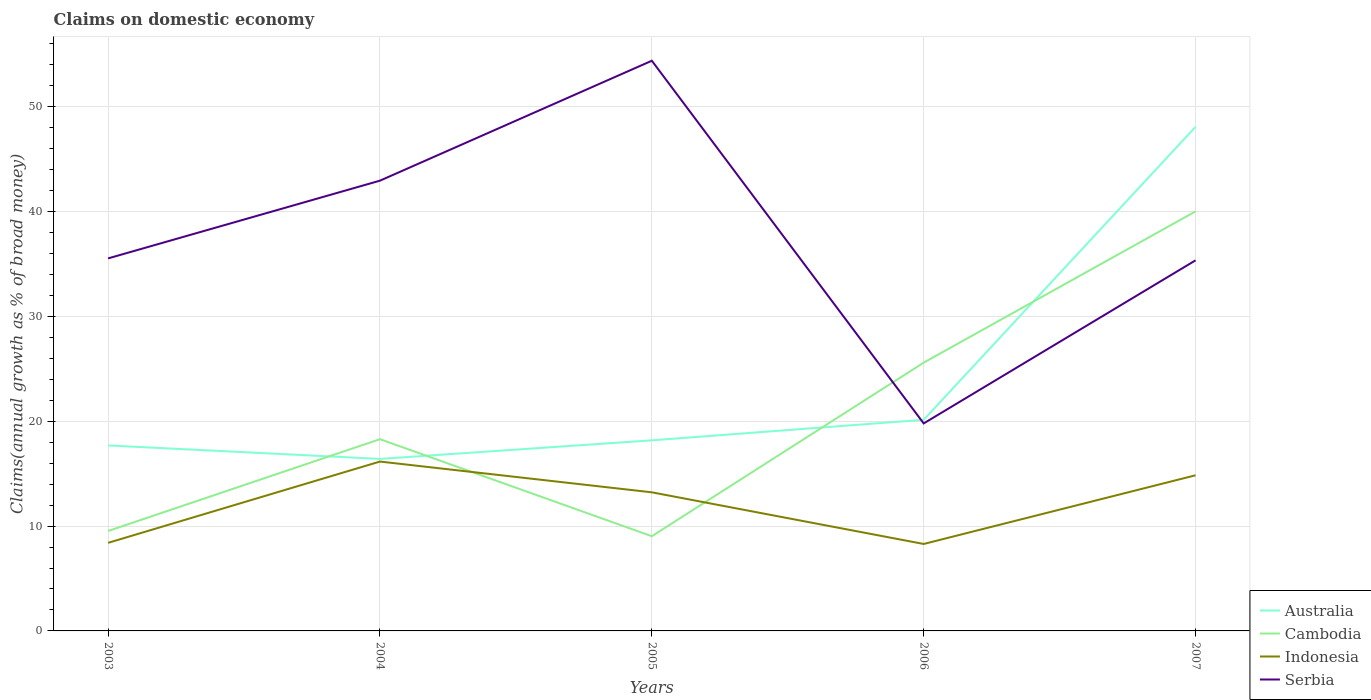How many different coloured lines are there?
Provide a short and direct response. 4. Does the line corresponding to Serbia intersect with the line corresponding to Australia?
Your answer should be very brief. Yes. Across all years, what is the maximum percentage of broad money claimed on domestic economy in Cambodia?
Your answer should be very brief. 9.03. In which year was the percentage of broad money claimed on domestic economy in Cambodia maximum?
Provide a succinct answer. 2005. What is the total percentage of broad money claimed on domestic economy in Cambodia in the graph?
Ensure brevity in your answer.  -30.99. What is the difference between the highest and the second highest percentage of broad money claimed on domestic economy in Serbia?
Your response must be concise. 34.6. What is the difference between the highest and the lowest percentage of broad money claimed on domestic economy in Serbia?
Your response must be concise. 2. Is the percentage of broad money claimed on domestic economy in Serbia strictly greater than the percentage of broad money claimed on domestic economy in Indonesia over the years?
Give a very brief answer. No. How many lines are there?
Ensure brevity in your answer.  4. What is the difference between two consecutive major ticks on the Y-axis?
Your response must be concise. 10. Where does the legend appear in the graph?
Keep it short and to the point. Bottom right. How are the legend labels stacked?
Provide a succinct answer. Vertical. What is the title of the graph?
Provide a succinct answer. Claims on domestic economy. Does "Central African Republic" appear as one of the legend labels in the graph?
Your answer should be very brief. No. What is the label or title of the X-axis?
Offer a terse response. Years. What is the label or title of the Y-axis?
Provide a short and direct response. Claims(annual growth as % of broad money). What is the Claims(annual growth as % of broad money) in Australia in 2003?
Provide a succinct answer. 17.69. What is the Claims(annual growth as % of broad money) of Cambodia in 2003?
Provide a short and direct response. 9.53. What is the Claims(annual growth as % of broad money) in Indonesia in 2003?
Provide a succinct answer. 8.4. What is the Claims(annual growth as % of broad money) in Serbia in 2003?
Offer a terse response. 35.54. What is the Claims(annual growth as % of broad money) of Australia in 2004?
Provide a succinct answer. 16.41. What is the Claims(annual growth as % of broad money) of Cambodia in 2004?
Make the answer very short. 18.29. What is the Claims(annual growth as % of broad money) of Indonesia in 2004?
Your answer should be very brief. 16.16. What is the Claims(annual growth as % of broad money) of Serbia in 2004?
Give a very brief answer. 42.96. What is the Claims(annual growth as % of broad money) of Australia in 2005?
Give a very brief answer. 18.18. What is the Claims(annual growth as % of broad money) of Cambodia in 2005?
Offer a very short reply. 9.03. What is the Claims(annual growth as % of broad money) in Indonesia in 2005?
Make the answer very short. 13.22. What is the Claims(annual growth as % of broad money) in Serbia in 2005?
Offer a very short reply. 54.4. What is the Claims(annual growth as % of broad money) in Australia in 2006?
Your answer should be very brief. 20.14. What is the Claims(annual growth as % of broad money) of Cambodia in 2006?
Your response must be concise. 25.6. What is the Claims(annual growth as % of broad money) of Indonesia in 2006?
Provide a short and direct response. 8.3. What is the Claims(annual growth as % of broad money) of Serbia in 2006?
Provide a succinct answer. 19.8. What is the Claims(annual growth as % of broad money) in Australia in 2007?
Your response must be concise. 48.1. What is the Claims(annual growth as % of broad money) in Cambodia in 2007?
Your response must be concise. 40.02. What is the Claims(annual growth as % of broad money) of Indonesia in 2007?
Your answer should be very brief. 14.85. What is the Claims(annual growth as % of broad money) in Serbia in 2007?
Give a very brief answer. 35.36. Across all years, what is the maximum Claims(annual growth as % of broad money) of Australia?
Your answer should be very brief. 48.1. Across all years, what is the maximum Claims(annual growth as % of broad money) of Cambodia?
Provide a succinct answer. 40.02. Across all years, what is the maximum Claims(annual growth as % of broad money) of Indonesia?
Offer a very short reply. 16.16. Across all years, what is the maximum Claims(annual growth as % of broad money) of Serbia?
Make the answer very short. 54.4. Across all years, what is the minimum Claims(annual growth as % of broad money) in Australia?
Provide a succinct answer. 16.41. Across all years, what is the minimum Claims(annual growth as % of broad money) in Cambodia?
Your answer should be compact. 9.03. Across all years, what is the minimum Claims(annual growth as % of broad money) of Indonesia?
Keep it short and to the point. 8.3. Across all years, what is the minimum Claims(annual growth as % of broad money) in Serbia?
Offer a very short reply. 19.8. What is the total Claims(annual growth as % of broad money) of Australia in the graph?
Make the answer very short. 120.53. What is the total Claims(annual growth as % of broad money) in Cambodia in the graph?
Your answer should be very brief. 102.48. What is the total Claims(annual growth as % of broad money) of Indonesia in the graph?
Provide a short and direct response. 60.93. What is the total Claims(annual growth as % of broad money) of Serbia in the graph?
Provide a short and direct response. 188.04. What is the difference between the Claims(annual growth as % of broad money) of Australia in 2003 and that in 2004?
Offer a very short reply. 1.28. What is the difference between the Claims(annual growth as % of broad money) of Cambodia in 2003 and that in 2004?
Make the answer very short. -8.76. What is the difference between the Claims(annual growth as % of broad money) of Indonesia in 2003 and that in 2004?
Provide a succinct answer. -7.76. What is the difference between the Claims(annual growth as % of broad money) of Serbia in 2003 and that in 2004?
Make the answer very short. -7.42. What is the difference between the Claims(annual growth as % of broad money) of Australia in 2003 and that in 2005?
Provide a short and direct response. -0.49. What is the difference between the Claims(annual growth as % of broad money) in Cambodia in 2003 and that in 2005?
Your answer should be very brief. 0.5. What is the difference between the Claims(annual growth as % of broad money) of Indonesia in 2003 and that in 2005?
Offer a terse response. -4.82. What is the difference between the Claims(annual growth as % of broad money) in Serbia in 2003 and that in 2005?
Offer a very short reply. -18.86. What is the difference between the Claims(annual growth as % of broad money) in Australia in 2003 and that in 2006?
Offer a terse response. -2.45. What is the difference between the Claims(annual growth as % of broad money) in Cambodia in 2003 and that in 2006?
Make the answer very short. -16.06. What is the difference between the Claims(annual growth as % of broad money) in Indonesia in 2003 and that in 2006?
Your response must be concise. 0.11. What is the difference between the Claims(annual growth as % of broad money) of Serbia in 2003 and that in 2006?
Make the answer very short. 15.74. What is the difference between the Claims(annual growth as % of broad money) of Australia in 2003 and that in 2007?
Provide a succinct answer. -30.4. What is the difference between the Claims(annual growth as % of broad money) of Cambodia in 2003 and that in 2007?
Provide a succinct answer. -30.49. What is the difference between the Claims(annual growth as % of broad money) in Indonesia in 2003 and that in 2007?
Your answer should be compact. -6.45. What is the difference between the Claims(annual growth as % of broad money) in Serbia in 2003 and that in 2007?
Your response must be concise. 0.18. What is the difference between the Claims(annual growth as % of broad money) of Australia in 2004 and that in 2005?
Offer a terse response. -1.77. What is the difference between the Claims(annual growth as % of broad money) in Cambodia in 2004 and that in 2005?
Your answer should be very brief. 9.26. What is the difference between the Claims(annual growth as % of broad money) of Indonesia in 2004 and that in 2005?
Give a very brief answer. 2.94. What is the difference between the Claims(annual growth as % of broad money) in Serbia in 2004 and that in 2005?
Ensure brevity in your answer.  -11.44. What is the difference between the Claims(annual growth as % of broad money) in Australia in 2004 and that in 2006?
Keep it short and to the point. -3.73. What is the difference between the Claims(annual growth as % of broad money) of Cambodia in 2004 and that in 2006?
Your response must be concise. -7.3. What is the difference between the Claims(annual growth as % of broad money) of Indonesia in 2004 and that in 2006?
Offer a very short reply. 7.86. What is the difference between the Claims(annual growth as % of broad money) in Serbia in 2004 and that in 2006?
Offer a terse response. 23.16. What is the difference between the Claims(annual growth as % of broad money) in Australia in 2004 and that in 2007?
Offer a terse response. -31.69. What is the difference between the Claims(annual growth as % of broad money) in Cambodia in 2004 and that in 2007?
Your answer should be compact. -21.73. What is the difference between the Claims(annual growth as % of broad money) in Indonesia in 2004 and that in 2007?
Offer a very short reply. 1.31. What is the difference between the Claims(annual growth as % of broad money) in Serbia in 2004 and that in 2007?
Your answer should be compact. 7.6. What is the difference between the Claims(annual growth as % of broad money) of Australia in 2005 and that in 2006?
Your response must be concise. -1.96. What is the difference between the Claims(annual growth as % of broad money) in Cambodia in 2005 and that in 2006?
Your answer should be compact. -16.56. What is the difference between the Claims(annual growth as % of broad money) of Indonesia in 2005 and that in 2006?
Offer a terse response. 4.93. What is the difference between the Claims(annual growth as % of broad money) in Serbia in 2005 and that in 2006?
Provide a short and direct response. 34.6. What is the difference between the Claims(annual growth as % of broad money) in Australia in 2005 and that in 2007?
Keep it short and to the point. -29.91. What is the difference between the Claims(annual growth as % of broad money) in Cambodia in 2005 and that in 2007?
Give a very brief answer. -30.99. What is the difference between the Claims(annual growth as % of broad money) in Indonesia in 2005 and that in 2007?
Provide a short and direct response. -1.63. What is the difference between the Claims(annual growth as % of broad money) of Serbia in 2005 and that in 2007?
Provide a short and direct response. 19.04. What is the difference between the Claims(annual growth as % of broad money) of Australia in 2006 and that in 2007?
Your answer should be compact. -27.95. What is the difference between the Claims(annual growth as % of broad money) of Cambodia in 2006 and that in 2007?
Your answer should be compact. -14.43. What is the difference between the Claims(annual growth as % of broad money) of Indonesia in 2006 and that in 2007?
Offer a terse response. -6.55. What is the difference between the Claims(annual growth as % of broad money) in Serbia in 2006 and that in 2007?
Your response must be concise. -15.56. What is the difference between the Claims(annual growth as % of broad money) in Australia in 2003 and the Claims(annual growth as % of broad money) in Cambodia in 2004?
Offer a terse response. -0.6. What is the difference between the Claims(annual growth as % of broad money) of Australia in 2003 and the Claims(annual growth as % of broad money) of Indonesia in 2004?
Offer a terse response. 1.54. What is the difference between the Claims(annual growth as % of broad money) in Australia in 2003 and the Claims(annual growth as % of broad money) in Serbia in 2004?
Provide a succinct answer. -25.26. What is the difference between the Claims(annual growth as % of broad money) in Cambodia in 2003 and the Claims(annual growth as % of broad money) in Indonesia in 2004?
Provide a succinct answer. -6.63. What is the difference between the Claims(annual growth as % of broad money) of Cambodia in 2003 and the Claims(annual growth as % of broad money) of Serbia in 2004?
Your answer should be very brief. -33.42. What is the difference between the Claims(annual growth as % of broad money) in Indonesia in 2003 and the Claims(annual growth as % of broad money) in Serbia in 2004?
Keep it short and to the point. -34.55. What is the difference between the Claims(annual growth as % of broad money) of Australia in 2003 and the Claims(annual growth as % of broad money) of Cambodia in 2005?
Keep it short and to the point. 8.66. What is the difference between the Claims(annual growth as % of broad money) of Australia in 2003 and the Claims(annual growth as % of broad money) of Indonesia in 2005?
Your answer should be compact. 4.47. What is the difference between the Claims(annual growth as % of broad money) in Australia in 2003 and the Claims(annual growth as % of broad money) in Serbia in 2005?
Provide a succinct answer. -36.7. What is the difference between the Claims(annual growth as % of broad money) in Cambodia in 2003 and the Claims(annual growth as % of broad money) in Indonesia in 2005?
Give a very brief answer. -3.69. What is the difference between the Claims(annual growth as % of broad money) in Cambodia in 2003 and the Claims(annual growth as % of broad money) in Serbia in 2005?
Provide a short and direct response. -44.86. What is the difference between the Claims(annual growth as % of broad money) in Indonesia in 2003 and the Claims(annual growth as % of broad money) in Serbia in 2005?
Your answer should be compact. -45.99. What is the difference between the Claims(annual growth as % of broad money) in Australia in 2003 and the Claims(annual growth as % of broad money) in Cambodia in 2006?
Give a very brief answer. -7.9. What is the difference between the Claims(annual growth as % of broad money) of Australia in 2003 and the Claims(annual growth as % of broad money) of Indonesia in 2006?
Your answer should be very brief. 9.4. What is the difference between the Claims(annual growth as % of broad money) of Australia in 2003 and the Claims(annual growth as % of broad money) of Serbia in 2006?
Provide a succinct answer. -2.1. What is the difference between the Claims(annual growth as % of broad money) in Cambodia in 2003 and the Claims(annual growth as % of broad money) in Indonesia in 2006?
Make the answer very short. 1.24. What is the difference between the Claims(annual growth as % of broad money) in Cambodia in 2003 and the Claims(annual growth as % of broad money) in Serbia in 2006?
Provide a short and direct response. -10.26. What is the difference between the Claims(annual growth as % of broad money) in Indonesia in 2003 and the Claims(annual growth as % of broad money) in Serbia in 2006?
Give a very brief answer. -11.39. What is the difference between the Claims(annual growth as % of broad money) in Australia in 2003 and the Claims(annual growth as % of broad money) in Cambodia in 2007?
Offer a terse response. -22.33. What is the difference between the Claims(annual growth as % of broad money) in Australia in 2003 and the Claims(annual growth as % of broad money) in Indonesia in 2007?
Keep it short and to the point. 2.85. What is the difference between the Claims(annual growth as % of broad money) of Australia in 2003 and the Claims(annual growth as % of broad money) of Serbia in 2007?
Your answer should be very brief. -17.66. What is the difference between the Claims(annual growth as % of broad money) of Cambodia in 2003 and the Claims(annual growth as % of broad money) of Indonesia in 2007?
Your response must be concise. -5.32. What is the difference between the Claims(annual growth as % of broad money) in Cambodia in 2003 and the Claims(annual growth as % of broad money) in Serbia in 2007?
Offer a very short reply. -25.82. What is the difference between the Claims(annual growth as % of broad money) in Indonesia in 2003 and the Claims(annual growth as % of broad money) in Serbia in 2007?
Make the answer very short. -26.95. What is the difference between the Claims(annual growth as % of broad money) of Australia in 2004 and the Claims(annual growth as % of broad money) of Cambodia in 2005?
Offer a terse response. 7.38. What is the difference between the Claims(annual growth as % of broad money) in Australia in 2004 and the Claims(annual growth as % of broad money) in Indonesia in 2005?
Keep it short and to the point. 3.19. What is the difference between the Claims(annual growth as % of broad money) in Australia in 2004 and the Claims(annual growth as % of broad money) in Serbia in 2005?
Ensure brevity in your answer.  -37.99. What is the difference between the Claims(annual growth as % of broad money) of Cambodia in 2004 and the Claims(annual growth as % of broad money) of Indonesia in 2005?
Provide a succinct answer. 5.07. What is the difference between the Claims(annual growth as % of broad money) in Cambodia in 2004 and the Claims(annual growth as % of broad money) in Serbia in 2005?
Provide a short and direct response. -36.1. What is the difference between the Claims(annual growth as % of broad money) of Indonesia in 2004 and the Claims(annual growth as % of broad money) of Serbia in 2005?
Give a very brief answer. -38.24. What is the difference between the Claims(annual growth as % of broad money) in Australia in 2004 and the Claims(annual growth as % of broad money) in Cambodia in 2006?
Your answer should be very brief. -9.19. What is the difference between the Claims(annual growth as % of broad money) in Australia in 2004 and the Claims(annual growth as % of broad money) in Indonesia in 2006?
Your answer should be compact. 8.11. What is the difference between the Claims(annual growth as % of broad money) in Australia in 2004 and the Claims(annual growth as % of broad money) in Serbia in 2006?
Your response must be concise. -3.39. What is the difference between the Claims(annual growth as % of broad money) in Cambodia in 2004 and the Claims(annual growth as % of broad money) in Indonesia in 2006?
Make the answer very short. 10. What is the difference between the Claims(annual growth as % of broad money) of Cambodia in 2004 and the Claims(annual growth as % of broad money) of Serbia in 2006?
Provide a succinct answer. -1.5. What is the difference between the Claims(annual growth as % of broad money) of Indonesia in 2004 and the Claims(annual growth as % of broad money) of Serbia in 2006?
Your response must be concise. -3.64. What is the difference between the Claims(annual growth as % of broad money) of Australia in 2004 and the Claims(annual growth as % of broad money) of Cambodia in 2007?
Provide a short and direct response. -23.61. What is the difference between the Claims(annual growth as % of broad money) in Australia in 2004 and the Claims(annual growth as % of broad money) in Indonesia in 2007?
Give a very brief answer. 1.56. What is the difference between the Claims(annual growth as % of broad money) of Australia in 2004 and the Claims(annual growth as % of broad money) of Serbia in 2007?
Offer a very short reply. -18.94. What is the difference between the Claims(annual growth as % of broad money) in Cambodia in 2004 and the Claims(annual growth as % of broad money) in Indonesia in 2007?
Keep it short and to the point. 3.44. What is the difference between the Claims(annual growth as % of broad money) of Cambodia in 2004 and the Claims(annual growth as % of broad money) of Serbia in 2007?
Keep it short and to the point. -17.06. What is the difference between the Claims(annual growth as % of broad money) in Indonesia in 2004 and the Claims(annual growth as % of broad money) in Serbia in 2007?
Provide a short and direct response. -19.2. What is the difference between the Claims(annual growth as % of broad money) of Australia in 2005 and the Claims(annual growth as % of broad money) of Cambodia in 2006?
Your answer should be very brief. -7.41. What is the difference between the Claims(annual growth as % of broad money) of Australia in 2005 and the Claims(annual growth as % of broad money) of Indonesia in 2006?
Provide a succinct answer. 9.89. What is the difference between the Claims(annual growth as % of broad money) of Australia in 2005 and the Claims(annual growth as % of broad money) of Serbia in 2006?
Your response must be concise. -1.61. What is the difference between the Claims(annual growth as % of broad money) in Cambodia in 2005 and the Claims(annual growth as % of broad money) in Indonesia in 2006?
Offer a very short reply. 0.74. What is the difference between the Claims(annual growth as % of broad money) in Cambodia in 2005 and the Claims(annual growth as % of broad money) in Serbia in 2006?
Provide a short and direct response. -10.76. What is the difference between the Claims(annual growth as % of broad money) of Indonesia in 2005 and the Claims(annual growth as % of broad money) of Serbia in 2006?
Make the answer very short. -6.57. What is the difference between the Claims(annual growth as % of broad money) of Australia in 2005 and the Claims(annual growth as % of broad money) of Cambodia in 2007?
Provide a succinct answer. -21.84. What is the difference between the Claims(annual growth as % of broad money) in Australia in 2005 and the Claims(annual growth as % of broad money) in Indonesia in 2007?
Provide a succinct answer. 3.33. What is the difference between the Claims(annual growth as % of broad money) in Australia in 2005 and the Claims(annual growth as % of broad money) in Serbia in 2007?
Keep it short and to the point. -17.17. What is the difference between the Claims(annual growth as % of broad money) of Cambodia in 2005 and the Claims(annual growth as % of broad money) of Indonesia in 2007?
Provide a short and direct response. -5.81. What is the difference between the Claims(annual growth as % of broad money) of Cambodia in 2005 and the Claims(annual growth as % of broad money) of Serbia in 2007?
Your answer should be very brief. -26.32. What is the difference between the Claims(annual growth as % of broad money) of Indonesia in 2005 and the Claims(annual growth as % of broad money) of Serbia in 2007?
Make the answer very short. -22.13. What is the difference between the Claims(annual growth as % of broad money) of Australia in 2006 and the Claims(annual growth as % of broad money) of Cambodia in 2007?
Provide a short and direct response. -19.88. What is the difference between the Claims(annual growth as % of broad money) of Australia in 2006 and the Claims(annual growth as % of broad money) of Indonesia in 2007?
Provide a succinct answer. 5.29. What is the difference between the Claims(annual growth as % of broad money) in Australia in 2006 and the Claims(annual growth as % of broad money) in Serbia in 2007?
Your answer should be very brief. -15.21. What is the difference between the Claims(annual growth as % of broad money) in Cambodia in 2006 and the Claims(annual growth as % of broad money) in Indonesia in 2007?
Offer a very short reply. 10.75. What is the difference between the Claims(annual growth as % of broad money) in Cambodia in 2006 and the Claims(annual growth as % of broad money) in Serbia in 2007?
Offer a terse response. -9.76. What is the difference between the Claims(annual growth as % of broad money) of Indonesia in 2006 and the Claims(annual growth as % of broad money) of Serbia in 2007?
Your answer should be compact. -27.06. What is the average Claims(annual growth as % of broad money) of Australia per year?
Keep it short and to the point. 24.11. What is the average Claims(annual growth as % of broad money) of Cambodia per year?
Give a very brief answer. 20.5. What is the average Claims(annual growth as % of broad money) in Indonesia per year?
Make the answer very short. 12.19. What is the average Claims(annual growth as % of broad money) of Serbia per year?
Provide a short and direct response. 37.61. In the year 2003, what is the difference between the Claims(annual growth as % of broad money) in Australia and Claims(annual growth as % of broad money) in Cambodia?
Your answer should be very brief. 8.16. In the year 2003, what is the difference between the Claims(annual growth as % of broad money) of Australia and Claims(annual growth as % of broad money) of Indonesia?
Your answer should be very brief. 9.29. In the year 2003, what is the difference between the Claims(annual growth as % of broad money) in Australia and Claims(annual growth as % of broad money) in Serbia?
Make the answer very short. -17.84. In the year 2003, what is the difference between the Claims(annual growth as % of broad money) of Cambodia and Claims(annual growth as % of broad money) of Indonesia?
Offer a terse response. 1.13. In the year 2003, what is the difference between the Claims(annual growth as % of broad money) in Cambodia and Claims(annual growth as % of broad money) in Serbia?
Provide a succinct answer. -26.01. In the year 2003, what is the difference between the Claims(annual growth as % of broad money) of Indonesia and Claims(annual growth as % of broad money) of Serbia?
Your answer should be compact. -27.14. In the year 2004, what is the difference between the Claims(annual growth as % of broad money) of Australia and Claims(annual growth as % of broad money) of Cambodia?
Offer a very short reply. -1.88. In the year 2004, what is the difference between the Claims(annual growth as % of broad money) of Australia and Claims(annual growth as % of broad money) of Indonesia?
Your answer should be compact. 0.25. In the year 2004, what is the difference between the Claims(annual growth as % of broad money) of Australia and Claims(annual growth as % of broad money) of Serbia?
Your answer should be very brief. -26.54. In the year 2004, what is the difference between the Claims(annual growth as % of broad money) in Cambodia and Claims(annual growth as % of broad money) in Indonesia?
Provide a succinct answer. 2.13. In the year 2004, what is the difference between the Claims(annual growth as % of broad money) of Cambodia and Claims(annual growth as % of broad money) of Serbia?
Your answer should be very brief. -24.66. In the year 2004, what is the difference between the Claims(annual growth as % of broad money) of Indonesia and Claims(annual growth as % of broad money) of Serbia?
Your answer should be very brief. -26.8. In the year 2005, what is the difference between the Claims(annual growth as % of broad money) of Australia and Claims(annual growth as % of broad money) of Cambodia?
Offer a very short reply. 9.15. In the year 2005, what is the difference between the Claims(annual growth as % of broad money) of Australia and Claims(annual growth as % of broad money) of Indonesia?
Your response must be concise. 4.96. In the year 2005, what is the difference between the Claims(annual growth as % of broad money) in Australia and Claims(annual growth as % of broad money) in Serbia?
Your answer should be very brief. -36.21. In the year 2005, what is the difference between the Claims(annual growth as % of broad money) in Cambodia and Claims(annual growth as % of broad money) in Indonesia?
Give a very brief answer. -4.19. In the year 2005, what is the difference between the Claims(annual growth as % of broad money) of Cambodia and Claims(annual growth as % of broad money) of Serbia?
Provide a short and direct response. -45.36. In the year 2005, what is the difference between the Claims(annual growth as % of broad money) in Indonesia and Claims(annual growth as % of broad money) in Serbia?
Make the answer very short. -41.17. In the year 2006, what is the difference between the Claims(annual growth as % of broad money) in Australia and Claims(annual growth as % of broad money) in Cambodia?
Provide a succinct answer. -5.45. In the year 2006, what is the difference between the Claims(annual growth as % of broad money) of Australia and Claims(annual growth as % of broad money) of Indonesia?
Provide a succinct answer. 11.85. In the year 2006, what is the difference between the Claims(annual growth as % of broad money) in Australia and Claims(annual growth as % of broad money) in Serbia?
Give a very brief answer. 0.34. In the year 2006, what is the difference between the Claims(annual growth as % of broad money) in Cambodia and Claims(annual growth as % of broad money) in Indonesia?
Offer a terse response. 17.3. In the year 2006, what is the difference between the Claims(annual growth as % of broad money) in Cambodia and Claims(annual growth as % of broad money) in Serbia?
Ensure brevity in your answer.  5.8. In the year 2006, what is the difference between the Claims(annual growth as % of broad money) of Indonesia and Claims(annual growth as % of broad money) of Serbia?
Your answer should be compact. -11.5. In the year 2007, what is the difference between the Claims(annual growth as % of broad money) of Australia and Claims(annual growth as % of broad money) of Cambodia?
Give a very brief answer. 8.07. In the year 2007, what is the difference between the Claims(annual growth as % of broad money) of Australia and Claims(annual growth as % of broad money) of Indonesia?
Offer a terse response. 33.25. In the year 2007, what is the difference between the Claims(annual growth as % of broad money) of Australia and Claims(annual growth as % of broad money) of Serbia?
Provide a short and direct response. 12.74. In the year 2007, what is the difference between the Claims(annual growth as % of broad money) of Cambodia and Claims(annual growth as % of broad money) of Indonesia?
Ensure brevity in your answer.  25.18. In the year 2007, what is the difference between the Claims(annual growth as % of broad money) of Cambodia and Claims(annual growth as % of broad money) of Serbia?
Offer a very short reply. 4.67. In the year 2007, what is the difference between the Claims(annual growth as % of broad money) in Indonesia and Claims(annual growth as % of broad money) in Serbia?
Offer a very short reply. -20.51. What is the ratio of the Claims(annual growth as % of broad money) of Australia in 2003 to that in 2004?
Ensure brevity in your answer.  1.08. What is the ratio of the Claims(annual growth as % of broad money) in Cambodia in 2003 to that in 2004?
Offer a terse response. 0.52. What is the ratio of the Claims(annual growth as % of broad money) of Indonesia in 2003 to that in 2004?
Your response must be concise. 0.52. What is the ratio of the Claims(annual growth as % of broad money) of Serbia in 2003 to that in 2004?
Offer a very short reply. 0.83. What is the ratio of the Claims(annual growth as % of broad money) of Australia in 2003 to that in 2005?
Your response must be concise. 0.97. What is the ratio of the Claims(annual growth as % of broad money) in Cambodia in 2003 to that in 2005?
Offer a terse response. 1.06. What is the ratio of the Claims(annual growth as % of broad money) in Indonesia in 2003 to that in 2005?
Offer a terse response. 0.64. What is the ratio of the Claims(annual growth as % of broad money) of Serbia in 2003 to that in 2005?
Provide a succinct answer. 0.65. What is the ratio of the Claims(annual growth as % of broad money) in Australia in 2003 to that in 2006?
Your answer should be very brief. 0.88. What is the ratio of the Claims(annual growth as % of broad money) of Cambodia in 2003 to that in 2006?
Your response must be concise. 0.37. What is the ratio of the Claims(annual growth as % of broad money) in Indonesia in 2003 to that in 2006?
Offer a terse response. 1.01. What is the ratio of the Claims(annual growth as % of broad money) in Serbia in 2003 to that in 2006?
Your answer should be compact. 1.8. What is the ratio of the Claims(annual growth as % of broad money) in Australia in 2003 to that in 2007?
Provide a short and direct response. 0.37. What is the ratio of the Claims(annual growth as % of broad money) of Cambodia in 2003 to that in 2007?
Offer a terse response. 0.24. What is the ratio of the Claims(annual growth as % of broad money) of Indonesia in 2003 to that in 2007?
Your response must be concise. 0.57. What is the ratio of the Claims(annual growth as % of broad money) of Serbia in 2003 to that in 2007?
Ensure brevity in your answer.  1.01. What is the ratio of the Claims(annual growth as % of broad money) in Australia in 2004 to that in 2005?
Your answer should be very brief. 0.9. What is the ratio of the Claims(annual growth as % of broad money) in Cambodia in 2004 to that in 2005?
Make the answer very short. 2.02. What is the ratio of the Claims(annual growth as % of broad money) in Indonesia in 2004 to that in 2005?
Give a very brief answer. 1.22. What is the ratio of the Claims(annual growth as % of broad money) in Serbia in 2004 to that in 2005?
Offer a very short reply. 0.79. What is the ratio of the Claims(annual growth as % of broad money) of Australia in 2004 to that in 2006?
Your answer should be very brief. 0.81. What is the ratio of the Claims(annual growth as % of broad money) in Cambodia in 2004 to that in 2006?
Offer a very short reply. 0.71. What is the ratio of the Claims(annual growth as % of broad money) in Indonesia in 2004 to that in 2006?
Provide a succinct answer. 1.95. What is the ratio of the Claims(annual growth as % of broad money) of Serbia in 2004 to that in 2006?
Ensure brevity in your answer.  2.17. What is the ratio of the Claims(annual growth as % of broad money) of Australia in 2004 to that in 2007?
Keep it short and to the point. 0.34. What is the ratio of the Claims(annual growth as % of broad money) of Cambodia in 2004 to that in 2007?
Give a very brief answer. 0.46. What is the ratio of the Claims(annual growth as % of broad money) of Indonesia in 2004 to that in 2007?
Offer a very short reply. 1.09. What is the ratio of the Claims(annual growth as % of broad money) in Serbia in 2004 to that in 2007?
Offer a very short reply. 1.22. What is the ratio of the Claims(annual growth as % of broad money) of Australia in 2005 to that in 2006?
Keep it short and to the point. 0.9. What is the ratio of the Claims(annual growth as % of broad money) in Cambodia in 2005 to that in 2006?
Provide a succinct answer. 0.35. What is the ratio of the Claims(annual growth as % of broad money) of Indonesia in 2005 to that in 2006?
Your response must be concise. 1.59. What is the ratio of the Claims(annual growth as % of broad money) of Serbia in 2005 to that in 2006?
Give a very brief answer. 2.75. What is the ratio of the Claims(annual growth as % of broad money) in Australia in 2005 to that in 2007?
Your answer should be compact. 0.38. What is the ratio of the Claims(annual growth as % of broad money) in Cambodia in 2005 to that in 2007?
Your response must be concise. 0.23. What is the ratio of the Claims(annual growth as % of broad money) in Indonesia in 2005 to that in 2007?
Make the answer very short. 0.89. What is the ratio of the Claims(annual growth as % of broad money) of Serbia in 2005 to that in 2007?
Keep it short and to the point. 1.54. What is the ratio of the Claims(annual growth as % of broad money) in Australia in 2006 to that in 2007?
Keep it short and to the point. 0.42. What is the ratio of the Claims(annual growth as % of broad money) in Cambodia in 2006 to that in 2007?
Offer a very short reply. 0.64. What is the ratio of the Claims(annual growth as % of broad money) in Indonesia in 2006 to that in 2007?
Provide a succinct answer. 0.56. What is the ratio of the Claims(annual growth as % of broad money) of Serbia in 2006 to that in 2007?
Your answer should be very brief. 0.56. What is the difference between the highest and the second highest Claims(annual growth as % of broad money) in Australia?
Give a very brief answer. 27.95. What is the difference between the highest and the second highest Claims(annual growth as % of broad money) in Cambodia?
Offer a terse response. 14.43. What is the difference between the highest and the second highest Claims(annual growth as % of broad money) in Indonesia?
Give a very brief answer. 1.31. What is the difference between the highest and the second highest Claims(annual growth as % of broad money) in Serbia?
Offer a terse response. 11.44. What is the difference between the highest and the lowest Claims(annual growth as % of broad money) in Australia?
Offer a very short reply. 31.69. What is the difference between the highest and the lowest Claims(annual growth as % of broad money) of Cambodia?
Offer a very short reply. 30.99. What is the difference between the highest and the lowest Claims(annual growth as % of broad money) of Indonesia?
Provide a succinct answer. 7.86. What is the difference between the highest and the lowest Claims(annual growth as % of broad money) in Serbia?
Give a very brief answer. 34.6. 